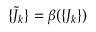Convert formula to latex. <formula><loc_0><loc_0><loc_500><loc_500>\{ { \tilde { J } } _ { k } \} = \beta ( \{ J _ { k } \} )</formula> 